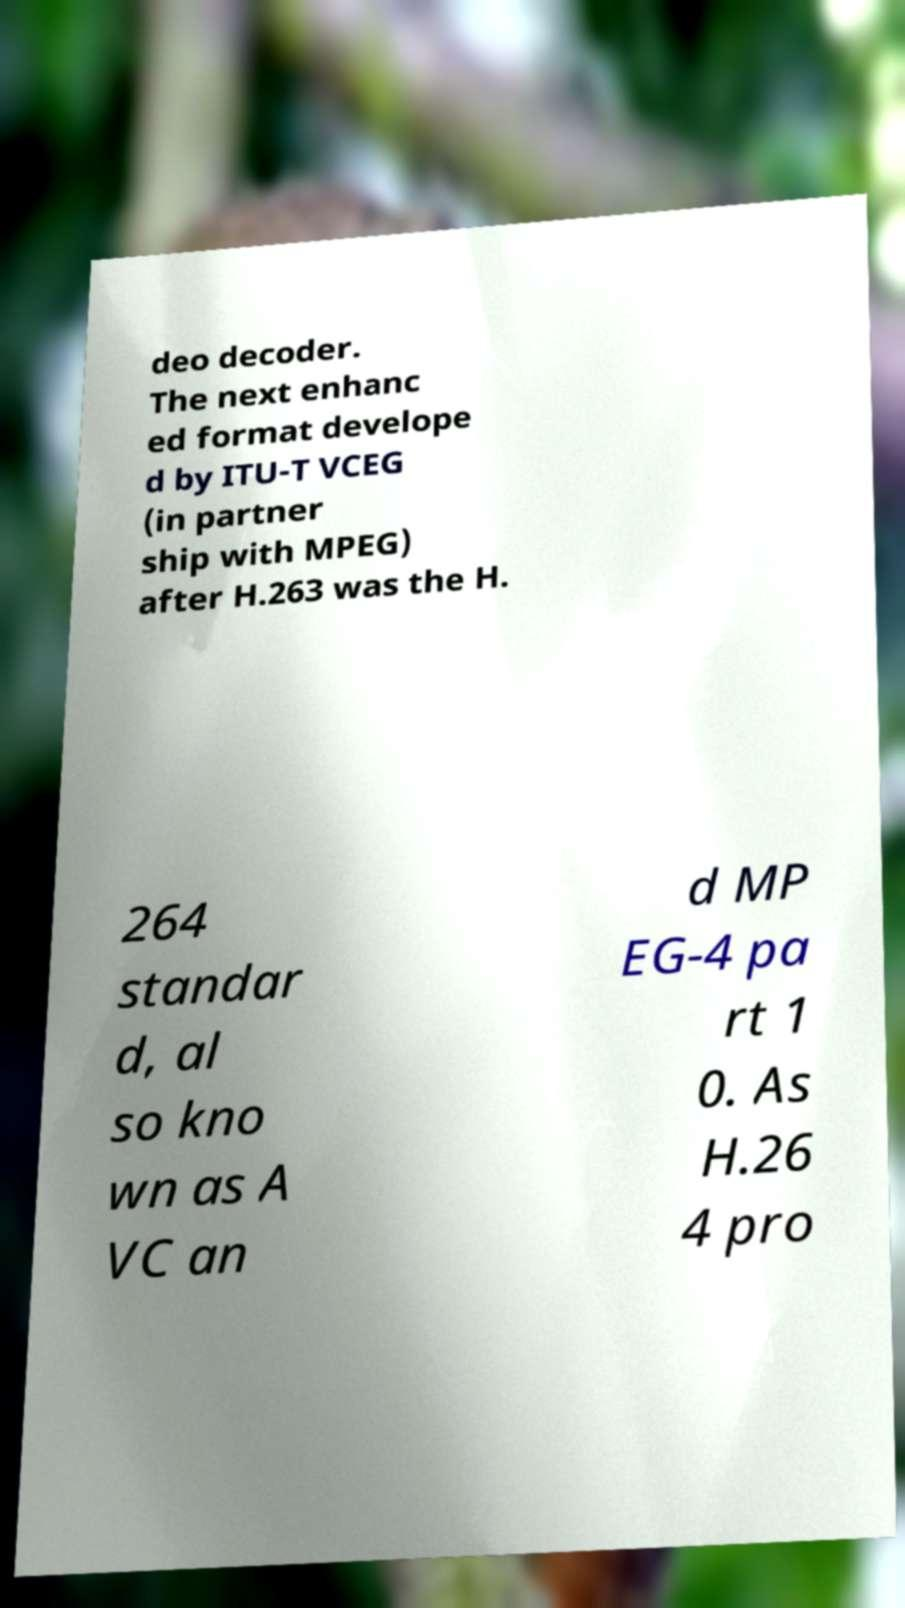What messages or text are displayed in this image? I need them in a readable, typed format. deo decoder. The next enhanc ed format develope d by ITU-T VCEG (in partner ship with MPEG) after H.263 was the H. 264 standar d, al so kno wn as A VC an d MP EG-4 pa rt 1 0. As H.26 4 pro 